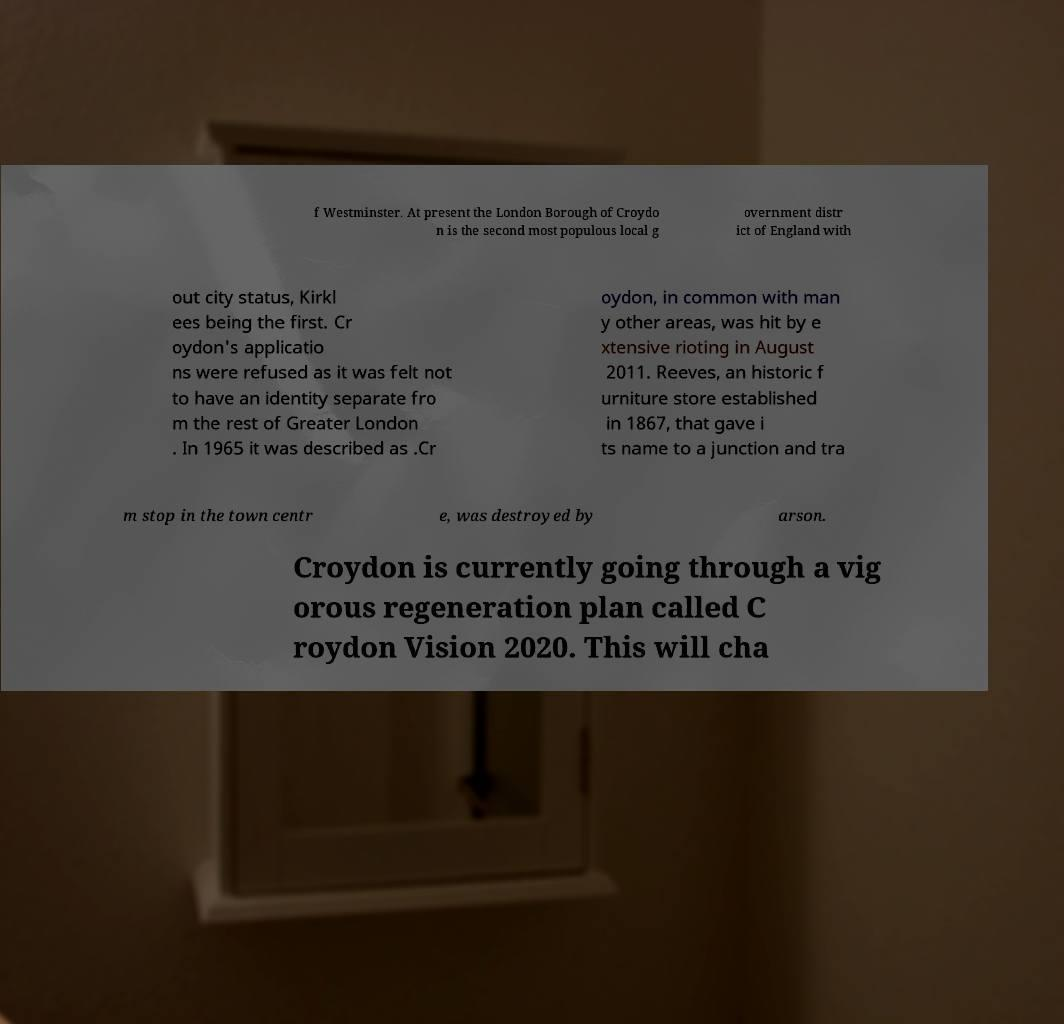Could you extract and type out the text from this image? f Westminster. At present the London Borough of Croydo n is the second most populous local g overnment distr ict of England with out city status, Kirkl ees being the first. Cr oydon's applicatio ns were refused as it was felt not to have an identity separate fro m the rest of Greater London . In 1965 it was described as .Cr oydon, in common with man y other areas, was hit by e xtensive rioting in August 2011. Reeves, an historic f urniture store established in 1867, that gave i ts name to a junction and tra m stop in the town centr e, was destroyed by arson. Croydon is currently going through a vig orous regeneration plan called C roydon Vision 2020. This will cha 